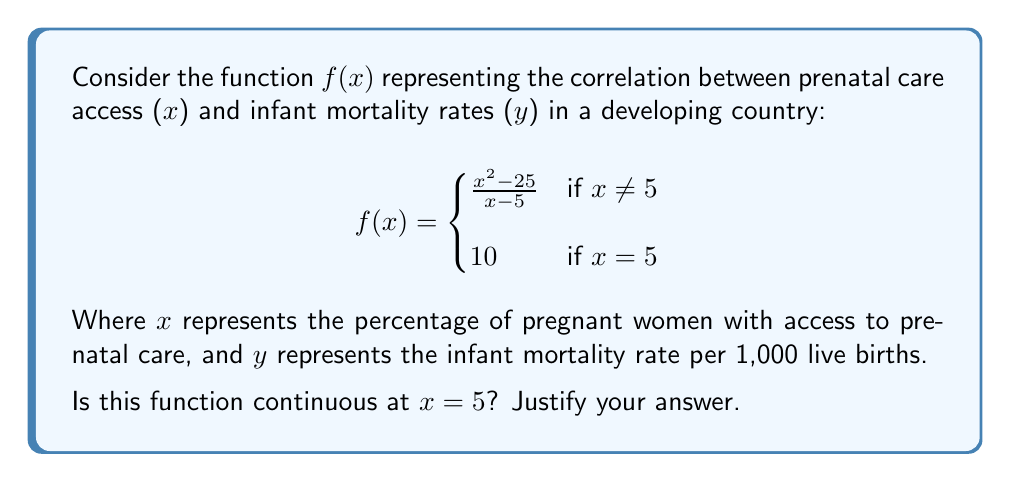Show me your answer to this math problem. To determine if the function is continuous at x = 5, we need to check three conditions:

1. The function must be defined at x = 5.
2. The limit of the function as x approaches 5 from both sides must exist.
3. The limit must equal the function value at x = 5.

Step 1: Check if f(5) is defined
From the piecewise definition, we see that f(5) = 10. So, the function is defined at x = 5.

Step 2: Calculate the limit as x approaches 5
Let's evaluate $\lim_{x \to 5} \frac{x^2 - 25}{x - 5}$

We can factor the numerator:
$$\lim_{x \to 5} \frac{(x+5)(x-5)}{x - 5}$$

The (x-5) terms cancel out:
$$\lim_{x \to 5} (x+5) = 10$$

So, the limit exists and equals 10.

Step 3: Compare the limit to the function value at x = 5
We found that $\lim_{x \to 5} f(x) = 10$, and f(5) = 10.

Since all three conditions are met:
1. f(5) is defined
2. $\lim_{x \to 5} f(x)$ exists
3. $\lim_{x \to 5} f(x) = f(5) = 10$

We can conclude that the function is continuous at x = 5.
Answer: Yes, the function is continuous at x = 5. 